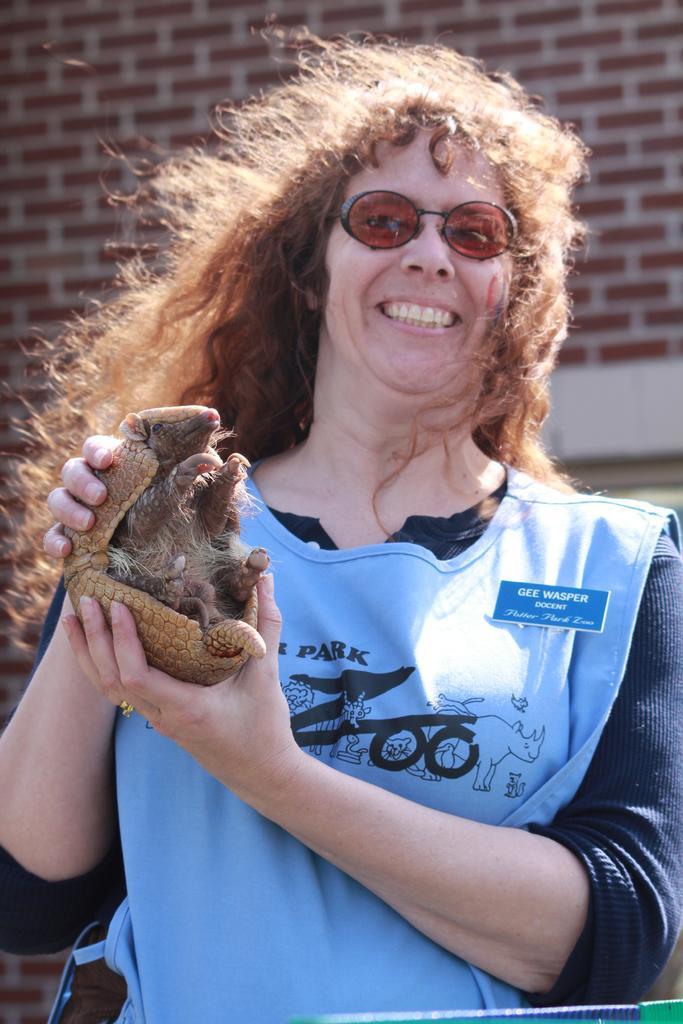Describe this image in one or two sentences. Here in this picture we can see a woman holding a small armadillo in her hands and we can see she is smiling and wearing goggles on her. 